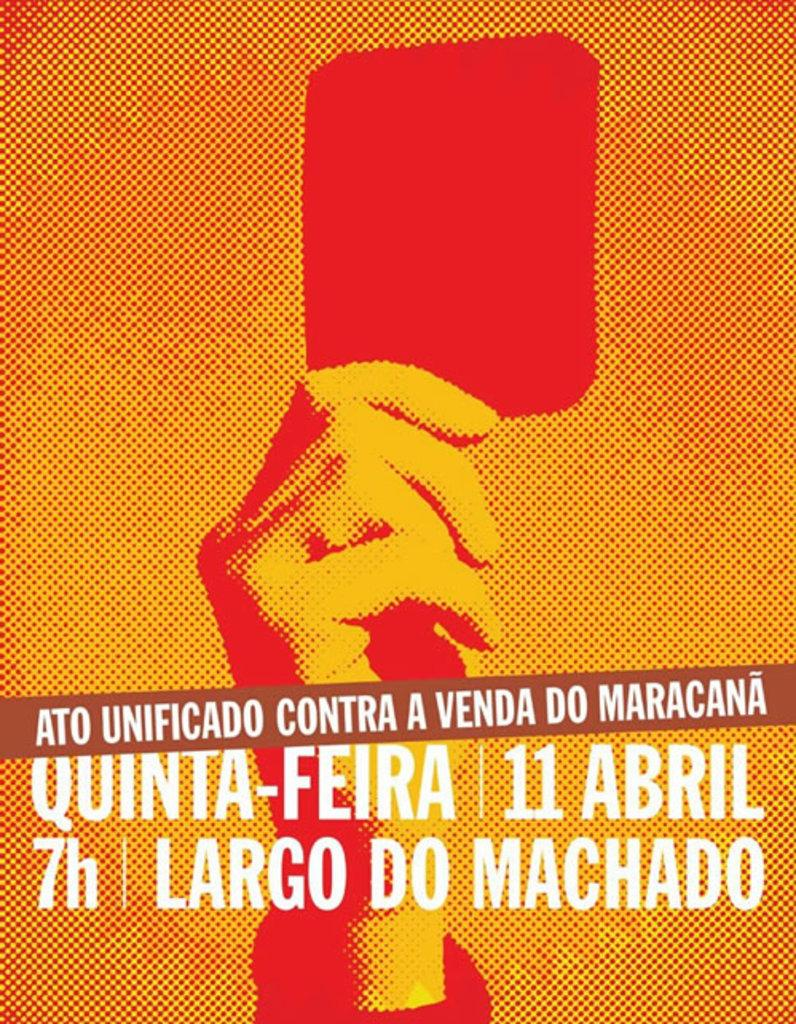<image>
Write a terse but informative summary of the picture. A poster of a man raising a red card announcing an event on the 11 of April at 7. 